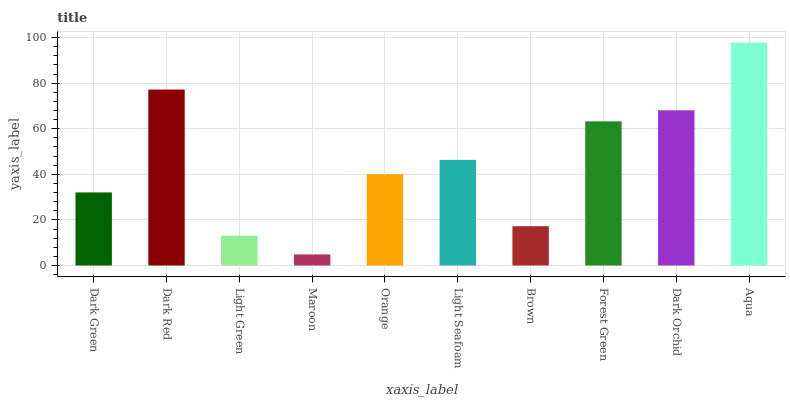Is Maroon the minimum?
Answer yes or no. Yes. Is Aqua the maximum?
Answer yes or no. Yes. Is Dark Red the minimum?
Answer yes or no. No. Is Dark Red the maximum?
Answer yes or no. No. Is Dark Red greater than Dark Green?
Answer yes or no. Yes. Is Dark Green less than Dark Red?
Answer yes or no. Yes. Is Dark Green greater than Dark Red?
Answer yes or no. No. Is Dark Red less than Dark Green?
Answer yes or no. No. Is Light Seafoam the high median?
Answer yes or no. Yes. Is Orange the low median?
Answer yes or no. Yes. Is Aqua the high median?
Answer yes or no. No. Is Forest Green the low median?
Answer yes or no. No. 